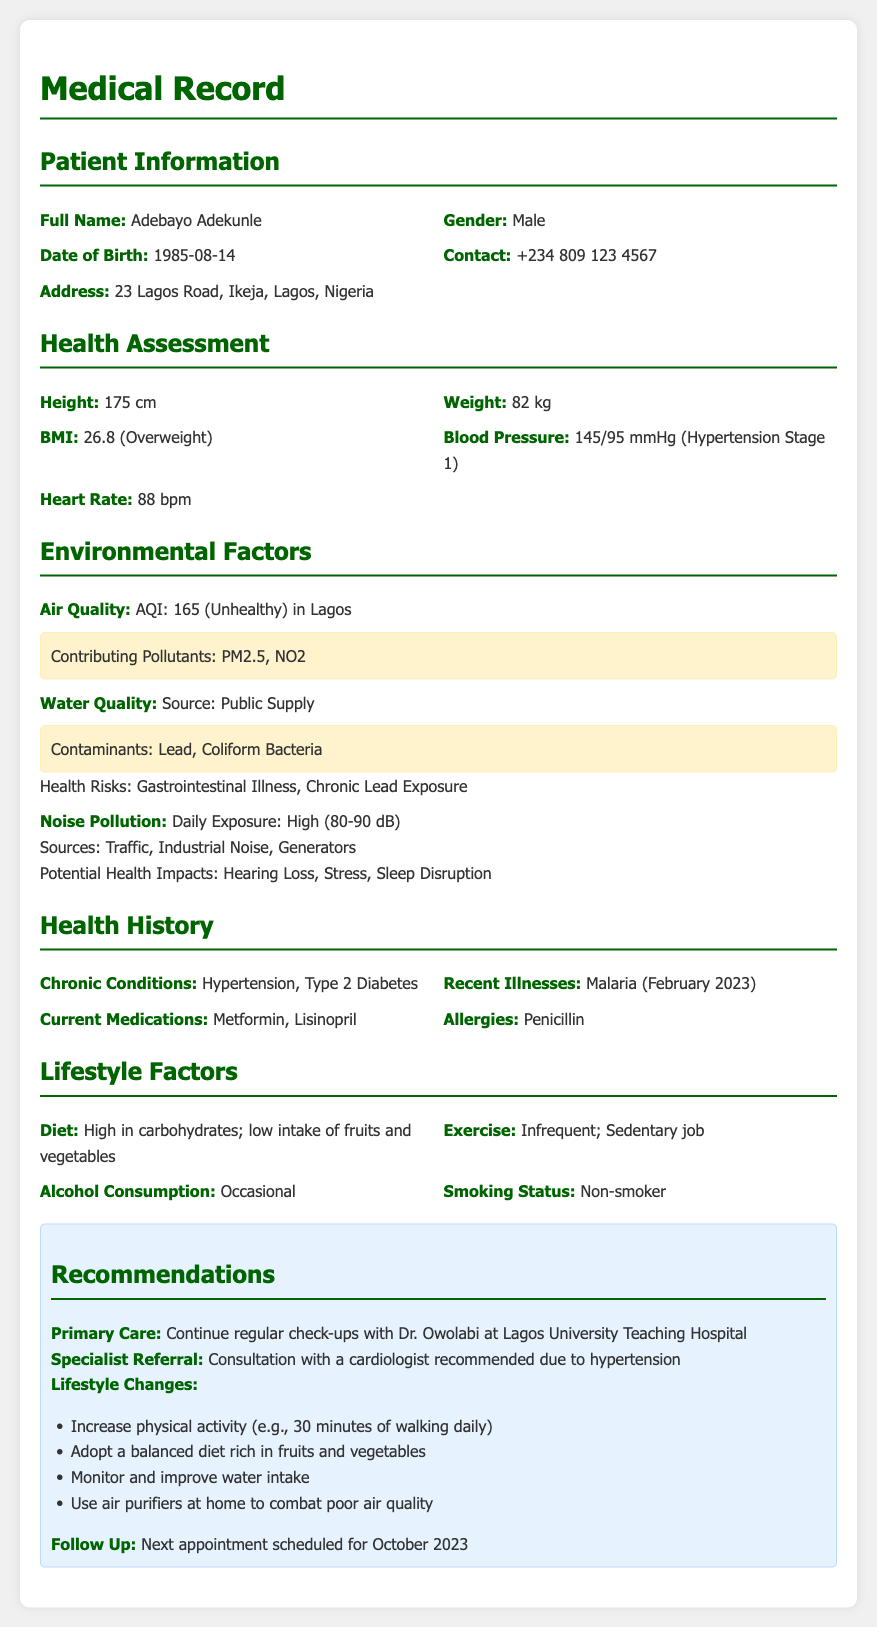what is the full name of the patient? The full name of the patient is stated in the Patient Information section.
Answer: Adebayo Adekunle what is the patient's date of birth? The date of birth is provided under Patient Information.
Answer: 1985-08-14 what is the blood pressure reading? The blood pressure is listed in the Health Assessment section.
Answer: 145/95 mmHg (Hypertension Stage 1) what are the contaminants in the water supply? The contaminants are mentioned in the Environmental Factors section.
Answer: Lead, Coliform Bacteria what is the daily exposure to noise pollution? The level of daily noise exposure is noted in the Environmental Factors section.
Answer: High (80-90 dB) what is the recommended exercise for the patient? The recommendation regarding exercise can be found in the section on Lifestyle Changes.
Answer: 30 minutes of walking daily what chronic conditions does the patient have? The chronic conditions are listed in the Health History section.
Answer: Hypertension, Type 2 Diabetes which doctor is the patient scheduled to see for follow-up? The primary care physician is mentioned in the Recommendations section.
Answer: Dr. Owolabi what is the next appointment date? The next appointment date is specified in the Follow Up section of Recommendations.
Answer: October 2023 